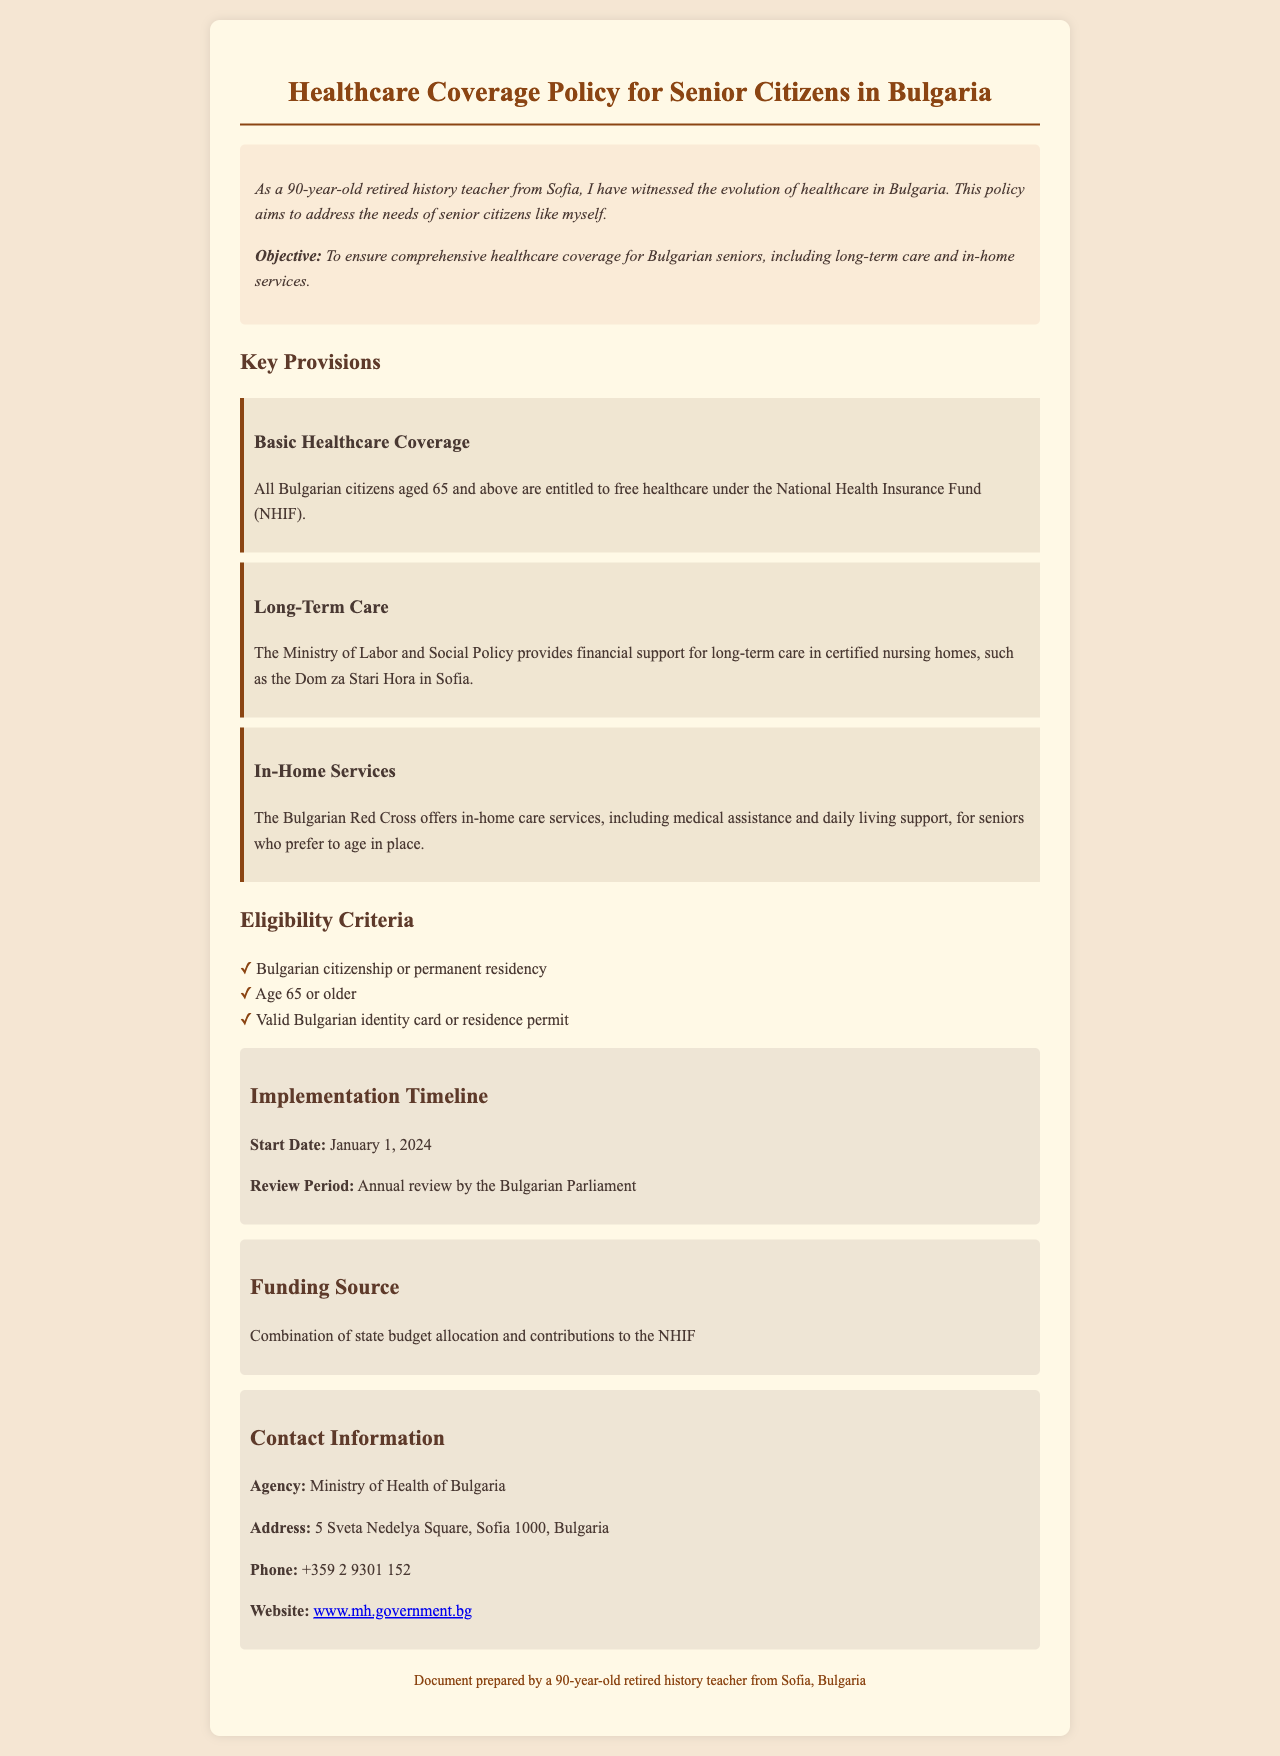what is the age requirement for healthcare coverage? The document states that individuals must be 65 years or older to be eligible for healthcare coverage under the policy.
Answer: 65 who provides financial support for long-term care? The long-term care financial support is provided by the Ministry of Labor and Social Policy.
Answer: Ministry of Labor and Social Policy when does the implementation of the policy begin? The start date for the implementation of the policy is explicitly mentioned in the document.
Answer: January 1, 2024 what organization offers in-home care services? In-home care services are offered by the Bulgarian Red Cross as outlined in the document.
Answer: Bulgarian Red Cross what are the eligibility criteria for senior citizens? The eligibility criteria for healthcare coverage include nationality, age, and identification requirements.
Answer: Bulgarian citizenship or permanent residency, age 65 or older, valid Bulgarian identity card or residence permit what is the contact number for the Ministry of Health? The document provides a specific contact number for inquiries related to healthcare coverage.
Answer: +359 2 9301 152 who prepared the document? The footnote of the document indicates the preparer of the healthcare policy document is a retired teacher.
Answer: a 90-year-old retired history teacher from Sofia, Bulgaria how often will the policy be reviewed? The document mentions a specific time frame for the review of the policy after its implementation.
Answer: Annual review 